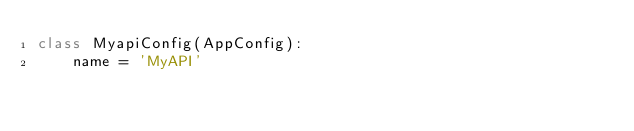<code> <loc_0><loc_0><loc_500><loc_500><_Python_>class MyapiConfig(AppConfig):
    name = 'MyAPI'
</code> 